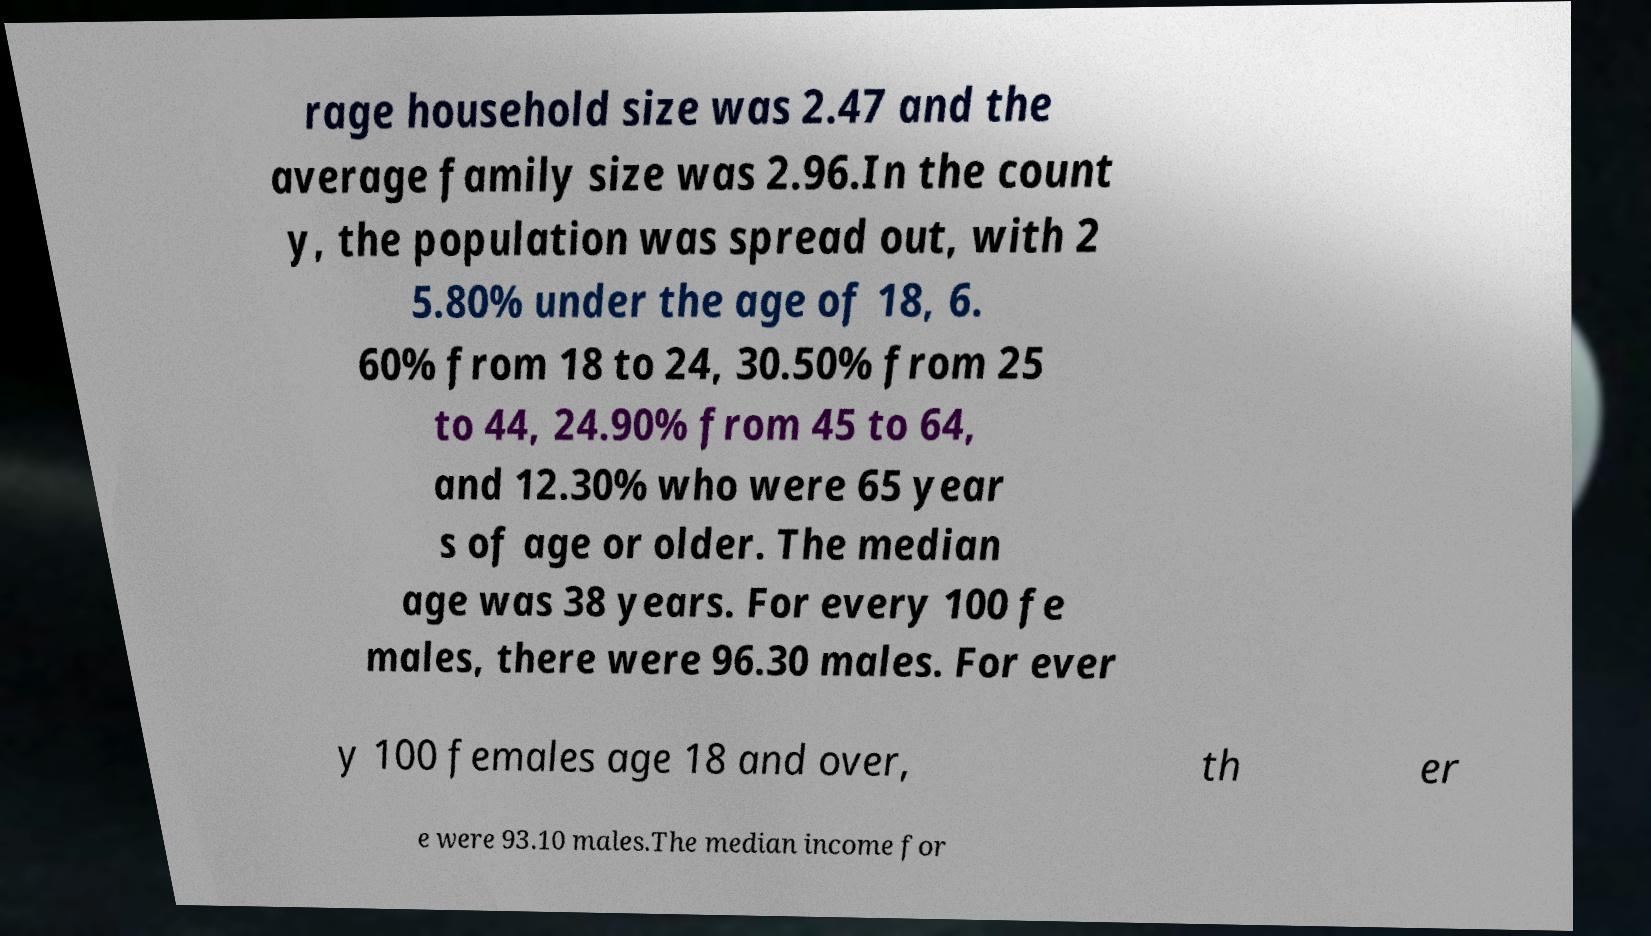Please read and relay the text visible in this image. What does it say? rage household size was 2.47 and the average family size was 2.96.In the count y, the population was spread out, with 2 5.80% under the age of 18, 6. 60% from 18 to 24, 30.50% from 25 to 44, 24.90% from 45 to 64, and 12.30% who were 65 year s of age or older. The median age was 38 years. For every 100 fe males, there were 96.30 males. For ever y 100 females age 18 and over, th er e were 93.10 males.The median income for 